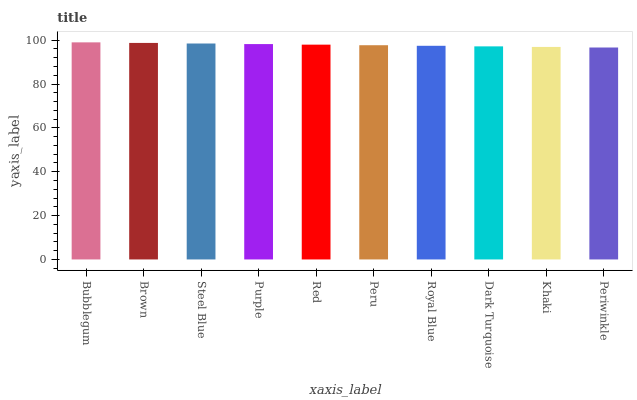Is Periwinkle the minimum?
Answer yes or no. Yes. Is Bubblegum the maximum?
Answer yes or no. Yes. Is Brown the minimum?
Answer yes or no. No. Is Brown the maximum?
Answer yes or no. No. Is Bubblegum greater than Brown?
Answer yes or no. Yes. Is Brown less than Bubblegum?
Answer yes or no. Yes. Is Brown greater than Bubblegum?
Answer yes or no. No. Is Bubblegum less than Brown?
Answer yes or no. No. Is Red the high median?
Answer yes or no. Yes. Is Peru the low median?
Answer yes or no. Yes. Is Dark Turquoise the high median?
Answer yes or no. No. Is Red the low median?
Answer yes or no. No. 